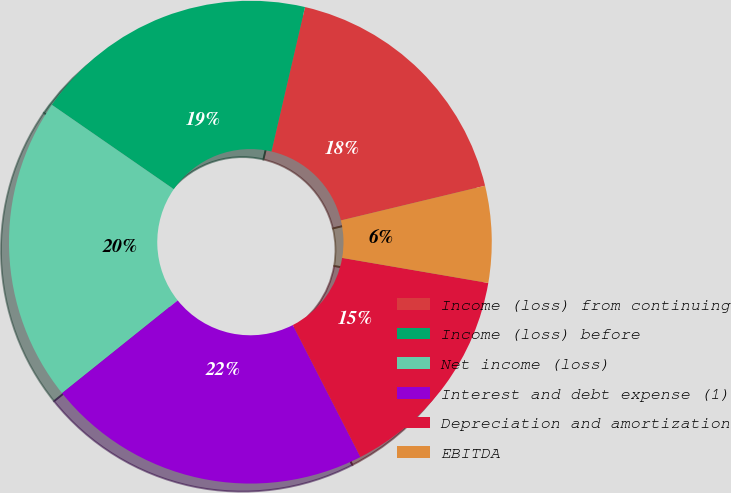Convert chart to OTSL. <chart><loc_0><loc_0><loc_500><loc_500><pie_chart><fcel>Income (loss) from continuing<fcel>Income (loss) before<fcel>Net income (loss)<fcel>Interest and debt expense (1)<fcel>Depreciation and amortization<fcel>EBITDA<nl><fcel>17.61%<fcel>19.0%<fcel>20.39%<fcel>21.78%<fcel>14.76%<fcel>6.46%<nl></chart> 